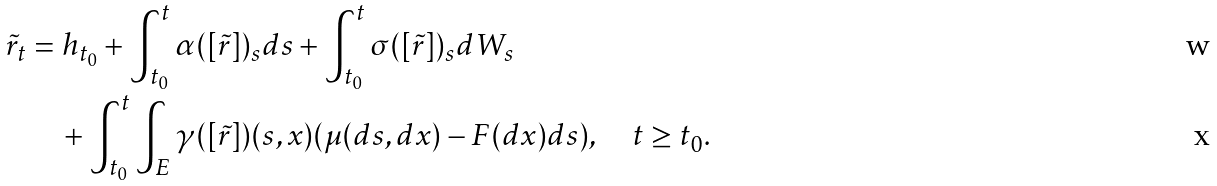Convert formula to latex. <formula><loc_0><loc_0><loc_500><loc_500>\tilde { r } _ { t } & = h _ { t _ { 0 } } + \int _ { t _ { 0 } } ^ { t } \alpha ( [ \tilde { r } ] ) _ { s } d s + \int _ { t _ { 0 } } ^ { t } \sigma ( [ \tilde { r } ] ) _ { s } d W _ { s } \\ & \quad + \int _ { t _ { 0 } } ^ { t } \int _ { E } \gamma ( [ \tilde { r } ] ) ( s , x ) ( \mu ( d s , d x ) - F ( d x ) d s ) , \quad t \geq t _ { 0 } .</formula> 